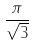Convert formula to latex. <formula><loc_0><loc_0><loc_500><loc_500>\frac { \pi } { \sqrt { 3 } }</formula> 